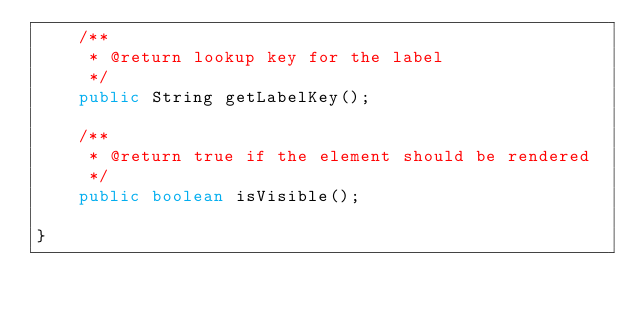<code> <loc_0><loc_0><loc_500><loc_500><_Java_>    /**
     * @return lookup key for the label
     */
    public String getLabelKey();

    /**
     * @return true if the element should be rendered
     */
    public boolean isVisible();

}
</code> 